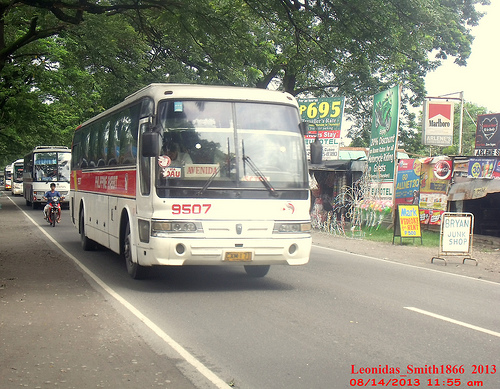Please provide the bounding box coordinate of the region this sentence describes: A person on a scooter behind the bus. The bounding box coordinate for a person on a scooter behind the bus is [0.07, 0.47, 0.12, 0.57]. 